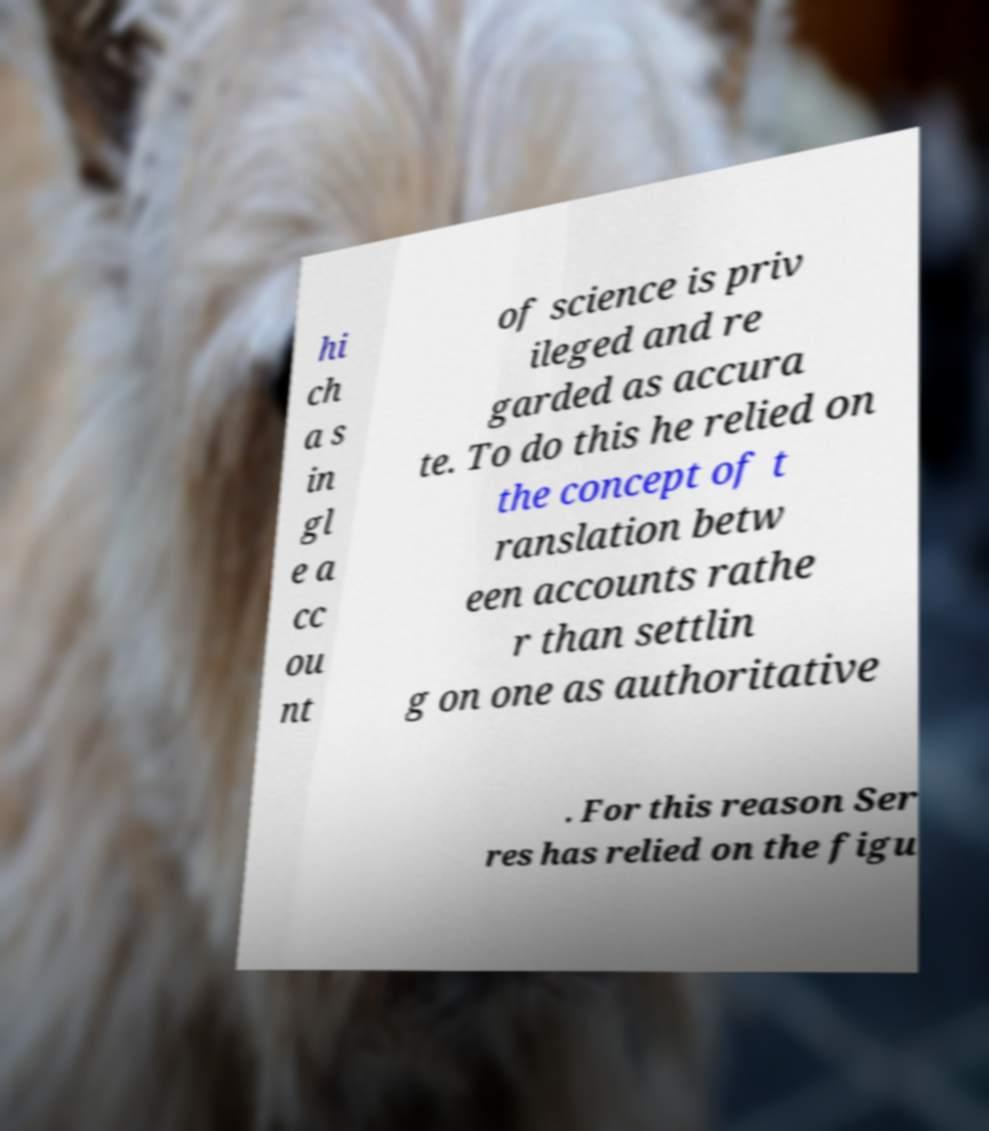Please identify and transcribe the text found in this image. hi ch a s in gl e a cc ou nt of science is priv ileged and re garded as accura te. To do this he relied on the concept of t ranslation betw een accounts rathe r than settlin g on one as authoritative . For this reason Ser res has relied on the figu 